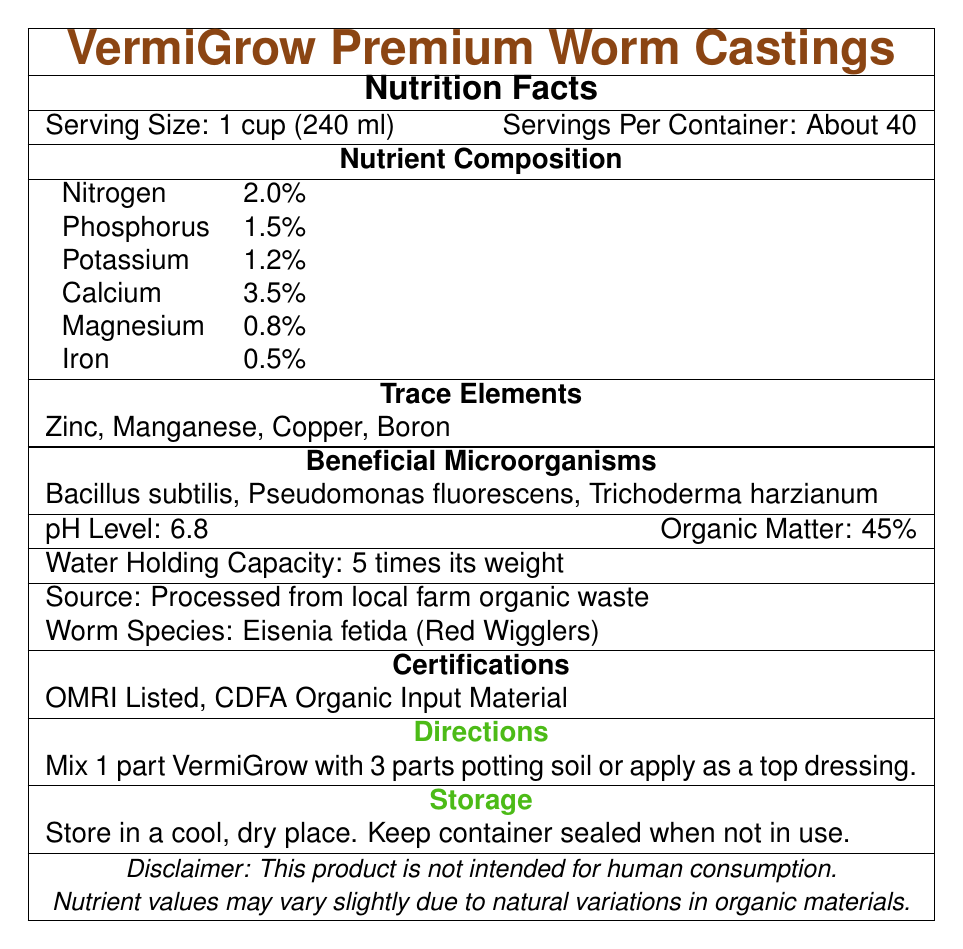what is the serving size for VermiGrow Premium Worm Castings? The serving size is clearly stated as "1 cup (240 ml)" at the beginning of the document.
Answer: 1 cup (240 ml) how many servings are there per container? The document specifies "Servings Per Container: About 40".
Answer: About 40 what is the nitrogen content in VermiGrow Premium Worm Castings? Under the Nutrient Composition section, the nitrogen content is listed as 2.0%.
Answer: 2.0% which beneficial microorganism is included in VermiGrow Premium Worm Castings? The Beneficial Microorganisms section lists Bacillus subtilis, Pseudomonas fluorescens, and Trichoderma harzianum.
Answer: Bacillus subtilis, Pseudomonas fluorescens, Trichoderma harzianum what is the recommended mixing ratio for VermiGrow and potting soil? The Directions section recommends mixing 1 part VermiGrow with 3 parts potting soil.
Answer: 1 part VermiGrow with 3 parts potting soil what is the source of the materials used to produce VermiGrow Premium Worm Castings? The Source section states that the materials are processed from local farm organic waste.
Answer: Processed from local farm organic waste how should VermiGrow Premium Worm Castings be stored? The Storage section specifies storing the product in a cool, dry place and keeping the container sealed when not in use.
Answer: Store in a cool, dry place. Keep container sealed when not in use. what is the pH level of VermiGrow Premium Worm Castings? The pH Level is specified as 6.8 in the document.
Answer: 6.8 which nutrient is present in the greatest amount in VermiGrow Premium Worm Castings? A. Nitrogen B. Phosphorus C. Calcium D. Magnesium Calcium is present at 3.5%, which is higher than any other nutrient listed.
Answer: C. Calcium which certification does VermiGrow Premium Worm Castings have? 1) USDA Organic 2) OMRI Listed 3) CDFA Organic Input Material 4) Both 2 and 3 The document lists VermiGrow as OMRI Listed and CDFA Organic Input Material certified.
Answer: 4) Both 2 and 3 can VermiGrow Premium Worm Castings be consumed by humans? The disclaimer clearly states, "This product is not intended for human consumption."
Answer: No does VermiGrow Premium Worm Castings include trace elements? The Trace Elements section lists Zinc, Manganese, Copper, and Boron as included trace elements.
Answer: Yes describe the entire document's main idea. The document covers all essential attributes of the product from its nutrient content to how to use and store it safely, emphasizing its organic and certified nature.
Answer: The document provides detailed information about VermiGrow Premium Worm Castings, including serving size, nutrient composition, pH level, beneficial microorganisms, trace elements, source of materials, worm species, certifications, usage directions, and storage instructions. does VermiGrow Premium Worm Castings contain any synthetic additives? The document does not provide any information about the presence or absence of synthetic additives.
Answer: Cannot be determined 